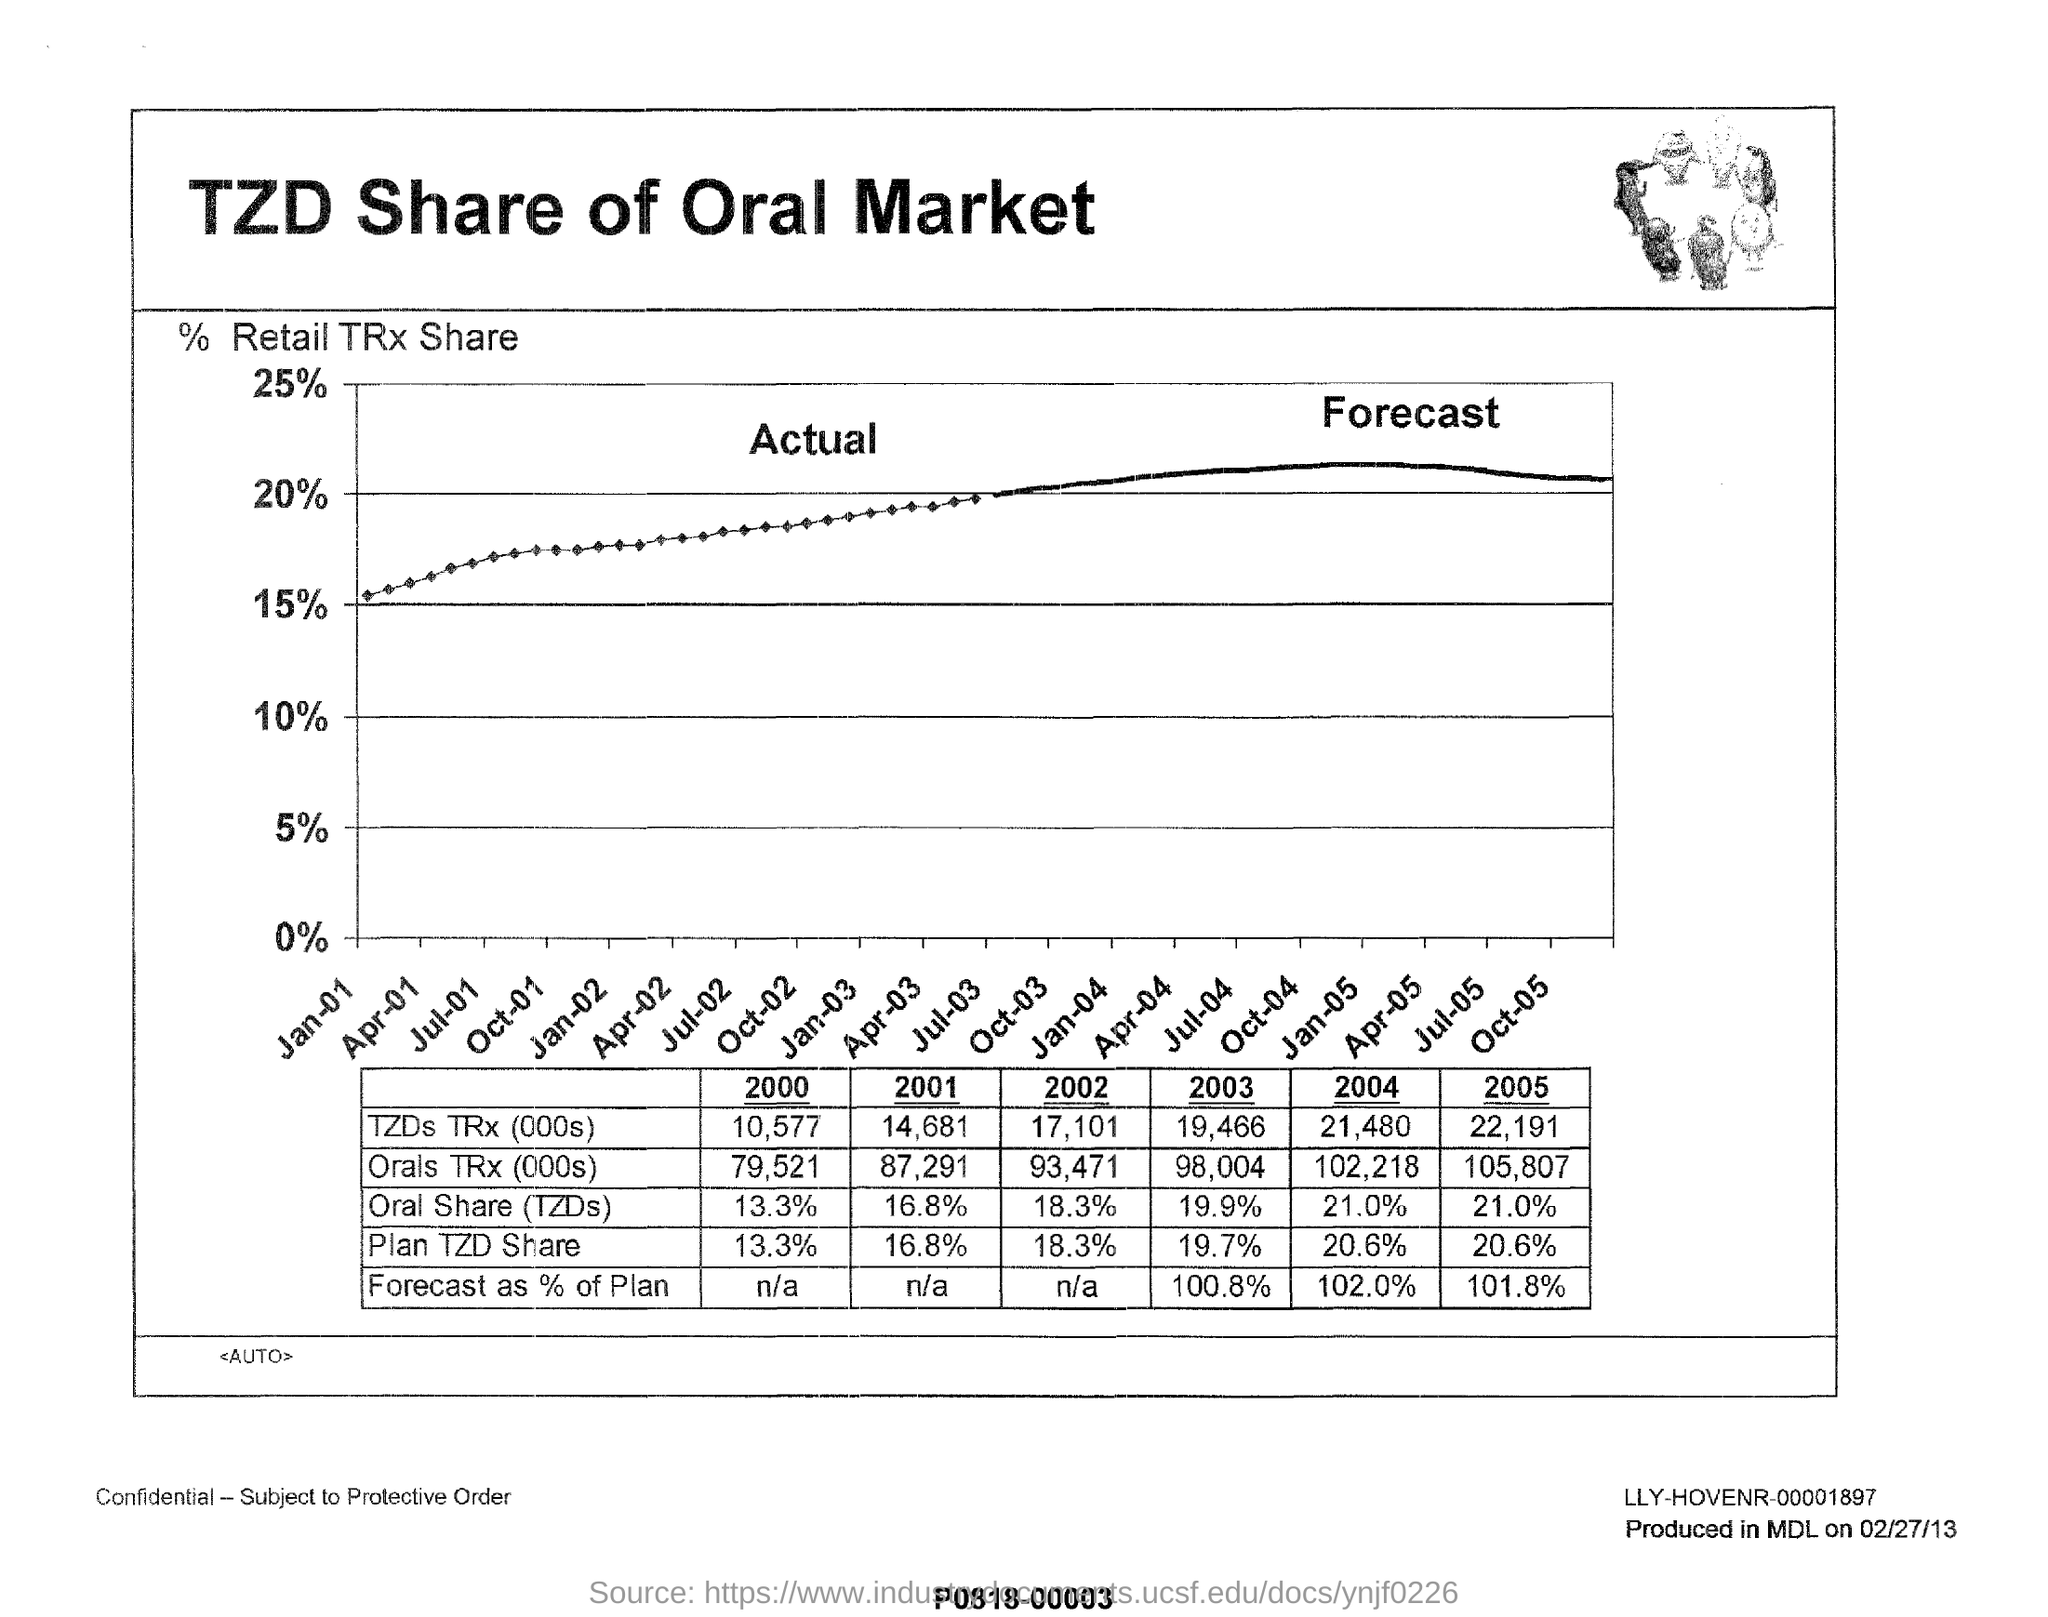Highlight a few significant elements in this photo. In the year 2000, the oral share of total revenue was 13.3%. The graph in this document describes the share of the oral market held by TZD. The Plan TZD Share for the year 2003 was 19.7%. 